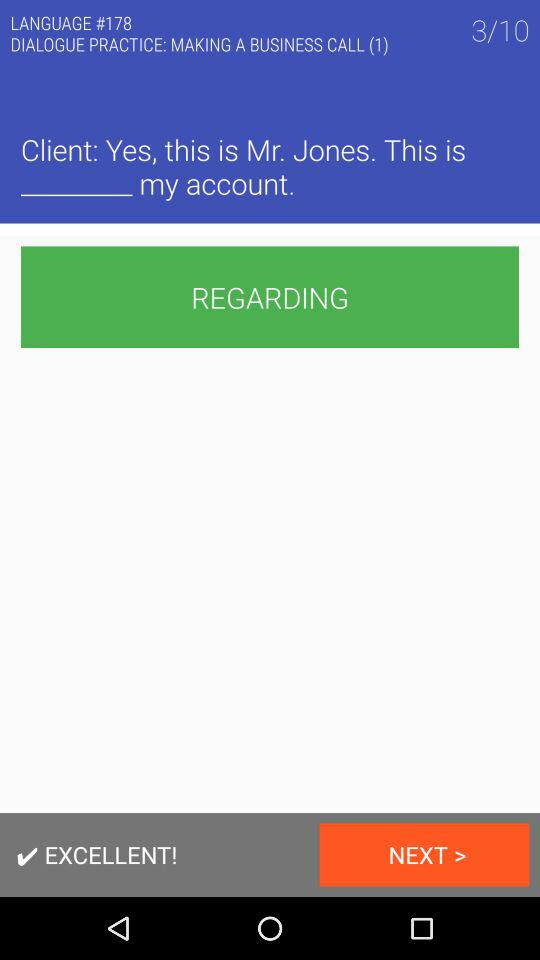What is the number of business calls?
When the provided information is insufficient, respond with <no answer>. <no answer> 